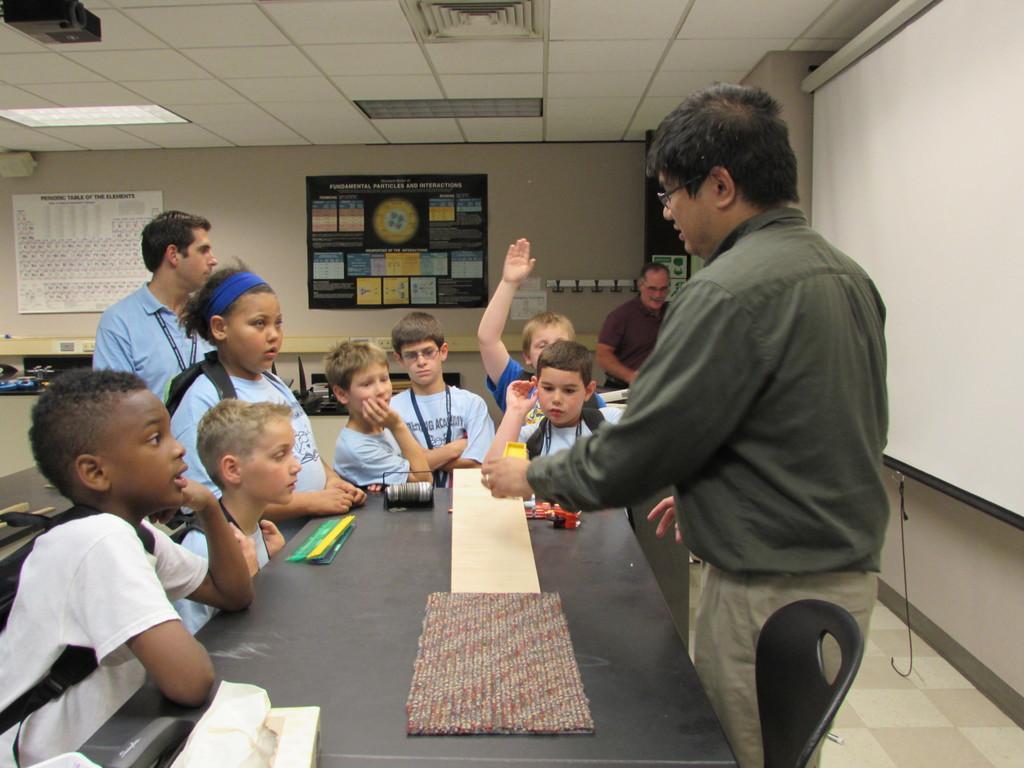Can you describe this image briefly? In this image we can see people, floor, table, chair, screen, and other objects. In the background we can see wall, ceiling, light, boards, and posters. 